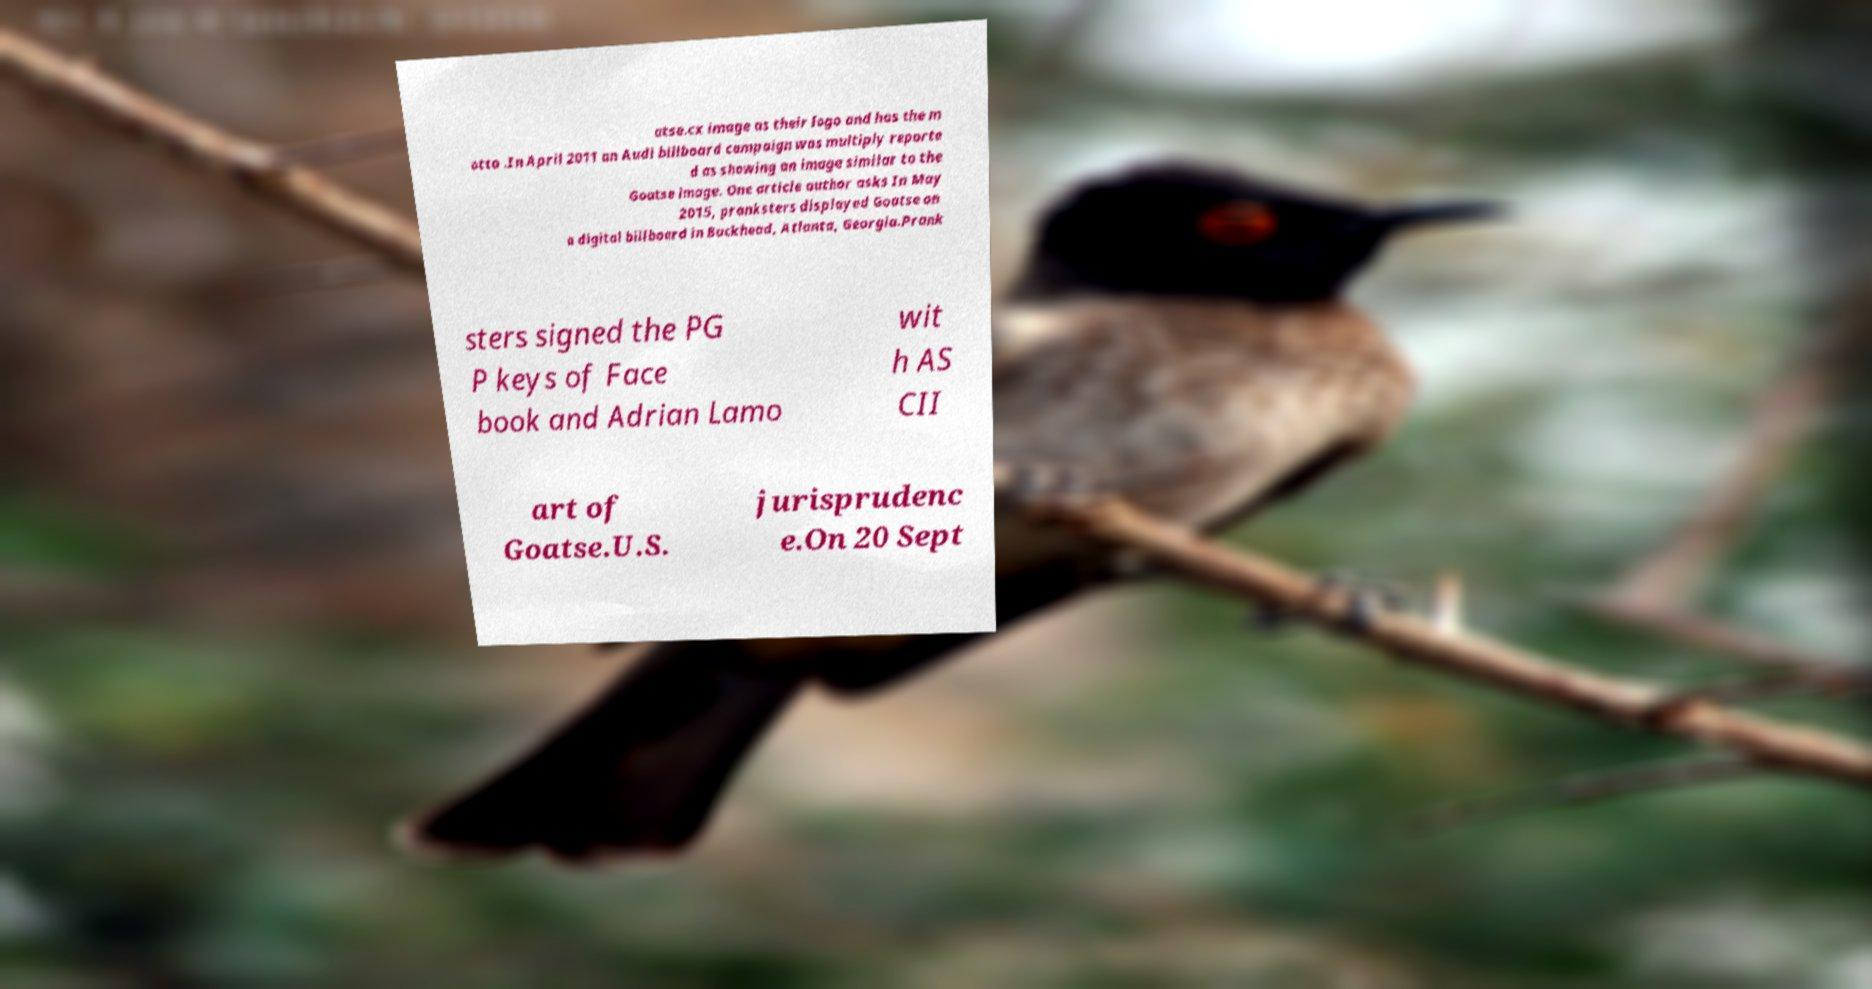What messages or text are displayed in this image? I need them in a readable, typed format. atse.cx image as their logo and has the m otto .In April 2011 an Audi billboard campaign was multiply reporte d as showing an image similar to the Goatse image. One article author asks In May 2015, pranksters displayed Goatse on a digital billboard in Buckhead, Atlanta, Georgia.Prank sters signed the PG P keys of Face book and Adrian Lamo wit h AS CII art of Goatse.U.S. jurisprudenc e.On 20 Sept 